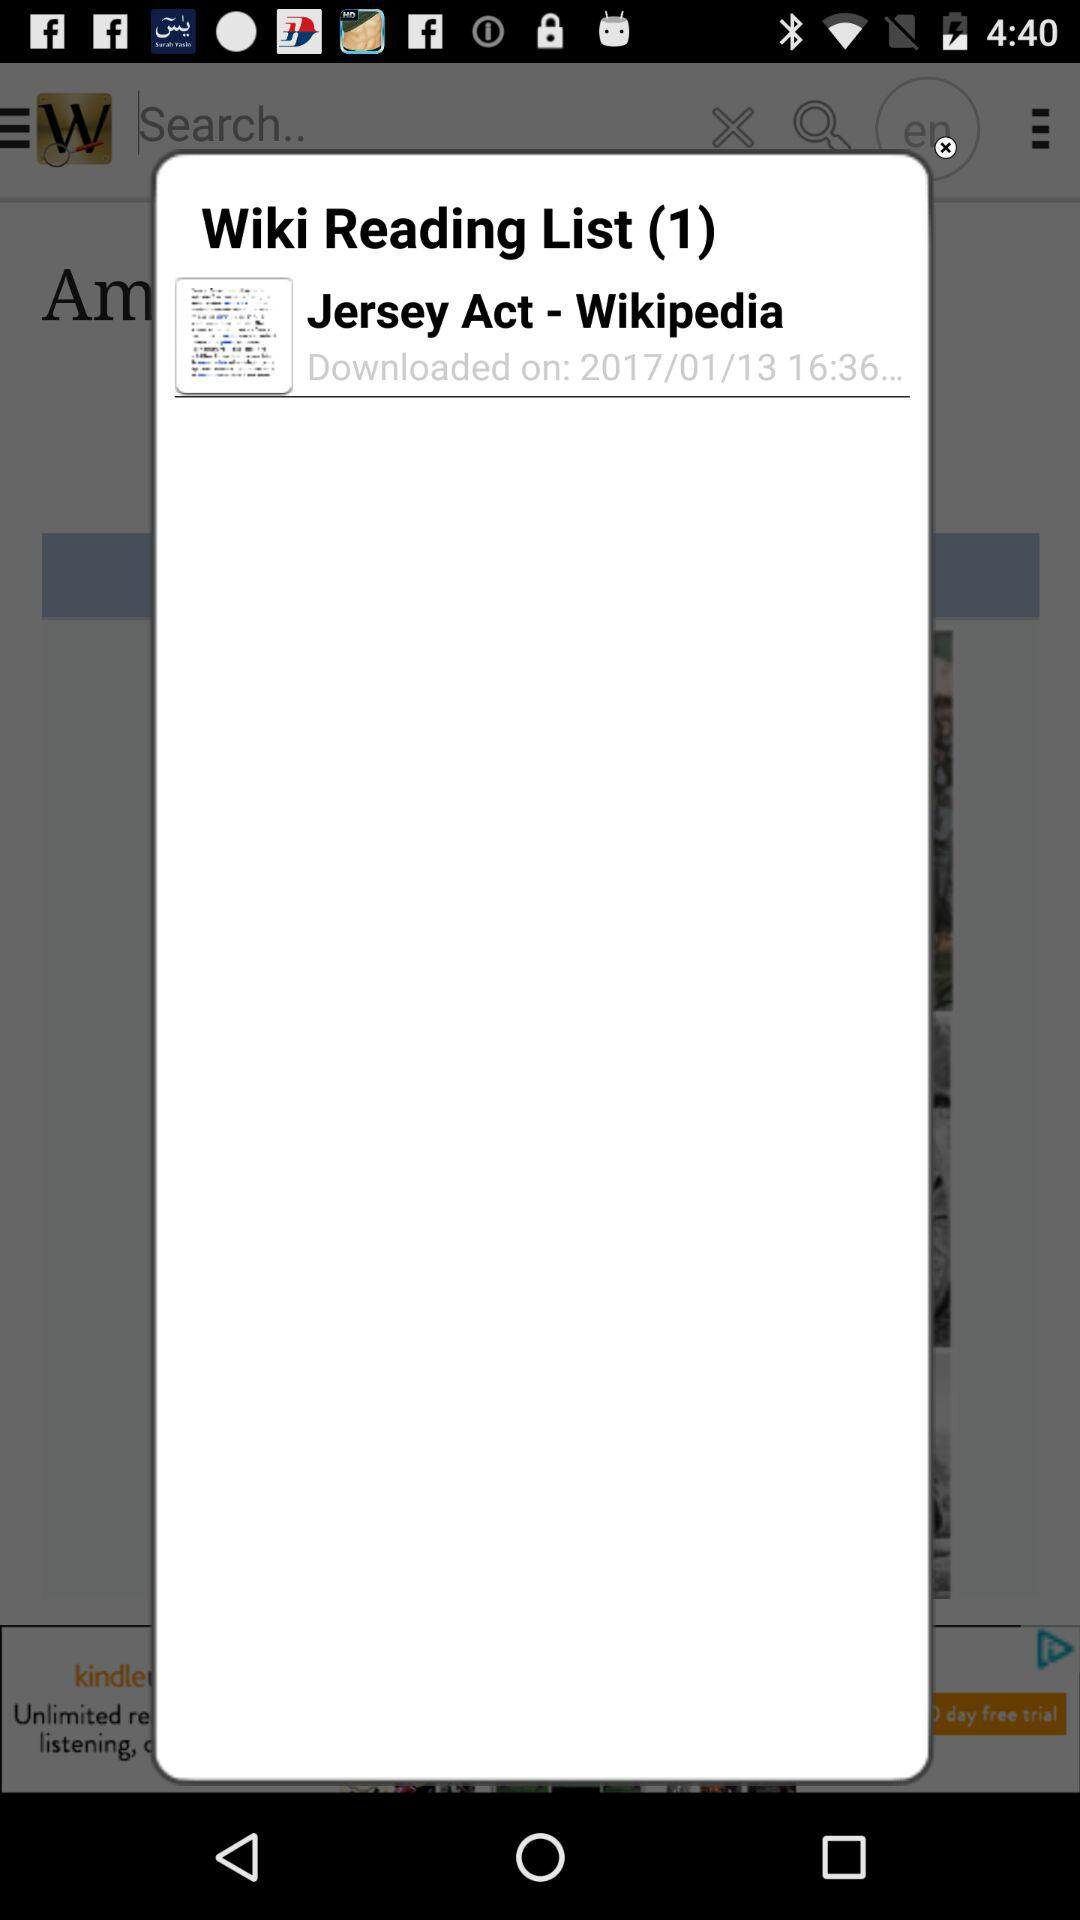What is the number of downloads in "Wiki Reading List"? The number of downloads is 1. 